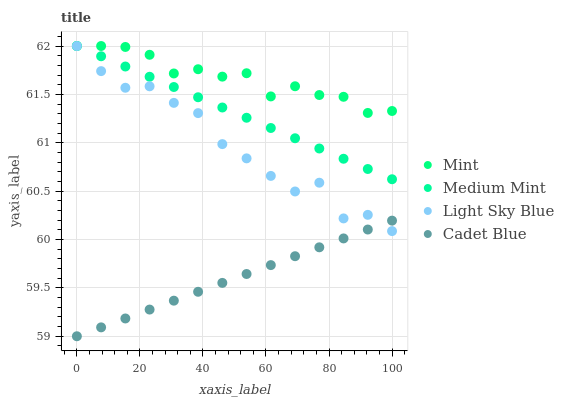Does Cadet Blue have the minimum area under the curve?
Answer yes or no. Yes. Does Mint have the maximum area under the curve?
Answer yes or no. Yes. Does Light Sky Blue have the minimum area under the curve?
Answer yes or no. No. Does Light Sky Blue have the maximum area under the curve?
Answer yes or no. No. Is Medium Mint the smoothest?
Answer yes or no. Yes. Is Light Sky Blue the roughest?
Answer yes or no. Yes. Is Mint the smoothest?
Answer yes or no. No. Is Mint the roughest?
Answer yes or no. No. Does Cadet Blue have the lowest value?
Answer yes or no. Yes. Does Light Sky Blue have the lowest value?
Answer yes or no. No. Does Mint have the highest value?
Answer yes or no. Yes. Does Cadet Blue have the highest value?
Answer yes or no. No. Is Cadet Blue less than Mint?
Answer yes or no. Yes. Is Medium Mint greater than Cadet Blue?
Answer yes or no. Yes. Does Medium Mint intersect Light Sky Blue?
Answer yes or no. Yes. Is Medium Mint less than Light Sky Blue?
Answer yes or no. No. Is Medium Mint greater than Light Sky Blue?
Answer yes or no. No. Does Cadet Blue intersect Mint?
Answer yes or no. No. 